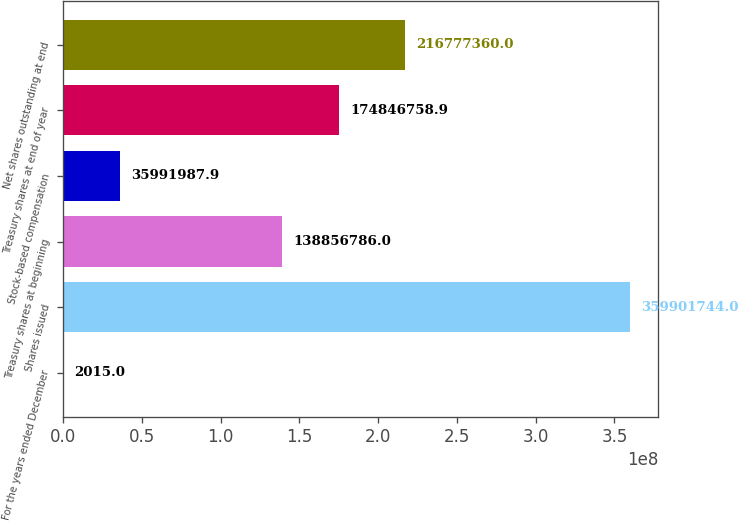<chart> <loc_0><loc_0><loc_500><loc_500><bar_chart><fcel>For the years ended December<fcel>Shares issued<fcel>Treasury shares at beginning<fcel>Stock-based compensation<fcel>Treasury shares at end of year<fcel>Net shares outstanding at end<nl><fcel>2015<fcel>3.59902e+08<fcel>1.38857e+08<fcel>3.5992e+07<fcel>1.74847e+08<fcel>2.16777e+08<nl></chart> 